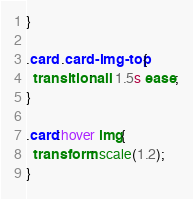Convert code to text. <code><loc_0><loc_0><loc_500><loc_500><_CSS_>}

.card .card-img-top{
  transition: all 1.5s ease;
}

.card:hover img{
  transform: scale(1.2);
}





</code> 